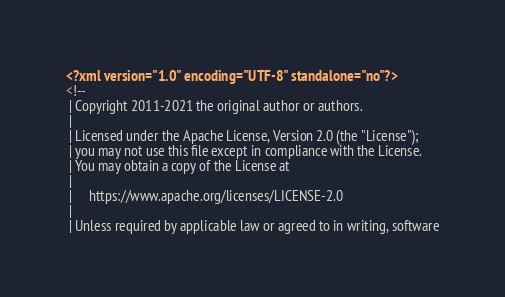<code> <loc_0><loc_0><loc_500><loc_500><_XML_><?xml version="1.0" encoding="UTF-8" standalone="no"?>
<!--
 | Copyright 2011-2021 the original author or authors.
 |
 | Licensed under the Apache License, Version 2.0 (the "License");
 | you may not use this file except in compliance with the License.
 | You may obtain a copy of the License at
 |
 |     https://www.apache.org/licenses/LICENSE-2.0
 |
 | Unless required by applicable law or agreed to in writing, software</code> 